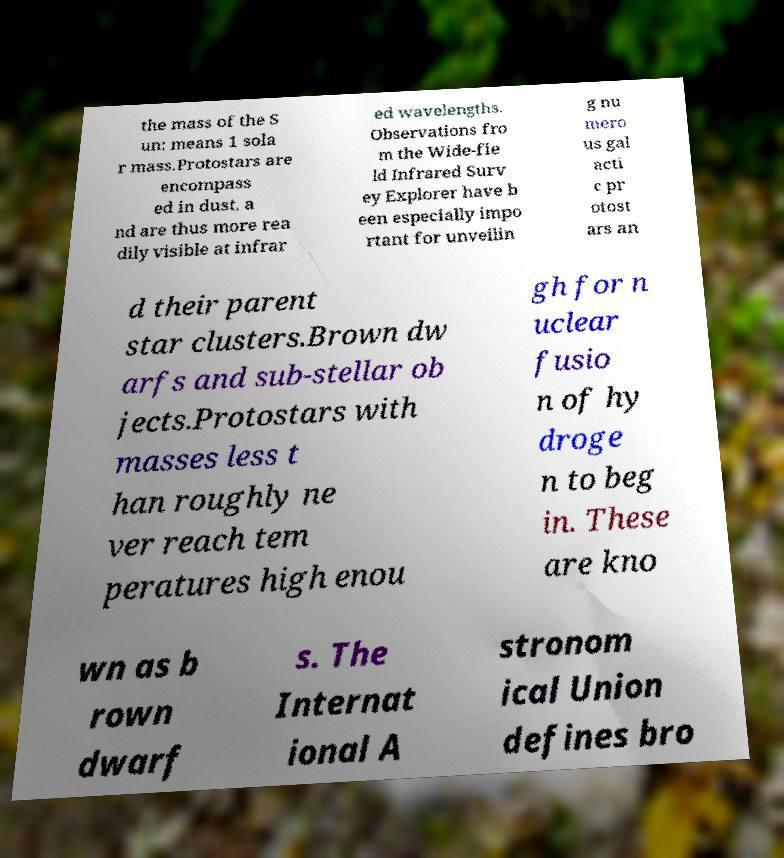What messages or text are displayed in this image? I need them in a readable, typed format. the mass of the S un: means 1 sola r mass.Protostars are encompass ed in dust, a nd are thus more rea dily visible at infrar ed wavelengths. Observations fro m the Wide-fie ld Infrared Surv ey Explorer have b een especially impo rtant for unveilin g nu mero us gal acti c pr otost ars an d their parent star clusters.Brown dw arfs and sub-stellar ob jects.Protostars with masses less t han roughly ne ver reach tem peratures high enou gh for n uclear fusio n of hy droge n to beg in. These are kno wn as b rown dwarf s. The Internat ional A stronom ical Union defines bro 